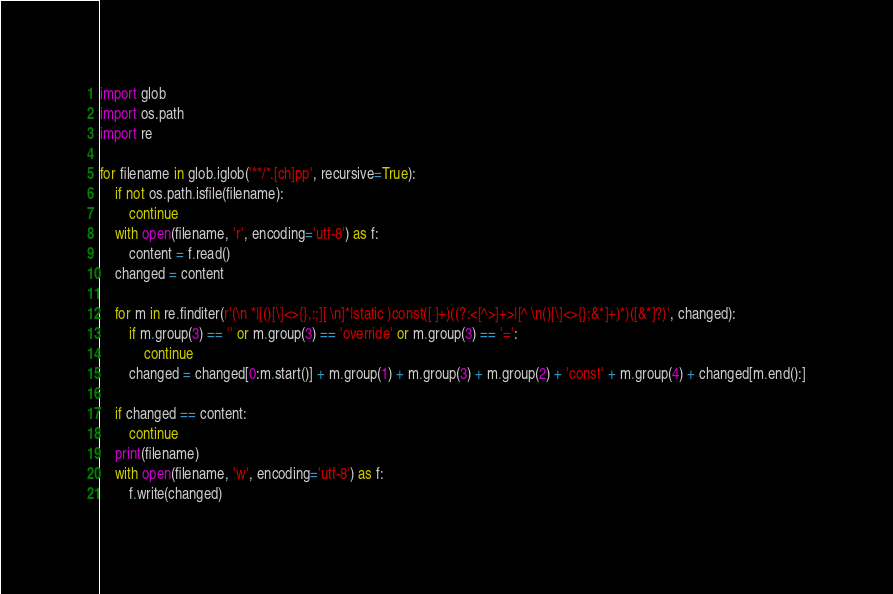<code> <loc_0><loc_0><loc_500><loc_500><_Python_>import glob
import os.path
import re

for filename in glob.iglob('**/*.[ch]pp', recursive=True):
    if not os.path.isfile(filename):
        continue
    with open(filename, 'r', encoding='utf-8') as f:
        content = f.read()
    changed = content

    for m in re.finditer(r'(\n *|[()[\]<>{},:;][ \n]*|static )const([ ]+)((?:<[^>]+>|[^ \n()[\]<>{};&*]+)*)([&*]?)', changed):
        if m.group(3) == '' or m.group(3) == 'override' or m.group(3) == '=':
            continue
        changed = changed[0:m.start()] + m.group(1) + m.group(3) + m.group(2) + 'const' + m.group(4) + changed[m.end():]

    if changed == content:
        continue
    print(filename)
    with open(filename, 'w', encoding='utf-8') as f:
        f.write(changed)
</code> 